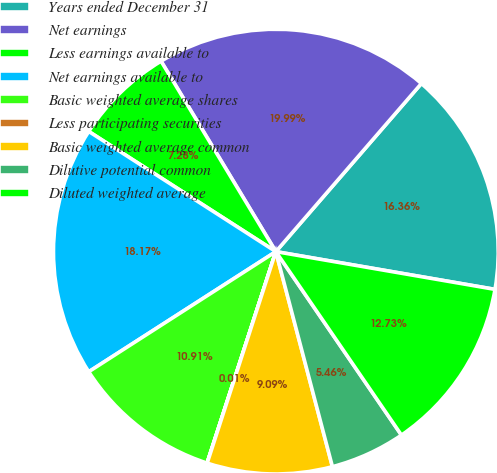Convert chart to OTSL. <chart><loc_0><loc_0><loc_500><loc_500><pie_chart><fcel>Years ended December 31<fcel>Net earnings<fcel>Less earnings available to<fcel>Net earnings available to<fcel>Basic weighted average shares<fcel>Less participating securities<fcel>Basic weighted average common<fcel>Dilutive potential common<fcel>Diluted weighted average<nl><fcel>16.36%<fcel>19.99%<fcel>7.28%<fcel>18.17%<fcel>10.91%<fcel>0.01%<fcel>9.09%<fcel>5.46%<fcel>12.73%<nl></chart> 